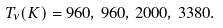Convert formula to latex. <formula><loc_0><loc_0><loc_500><loc_500>T _ { \nu } ( K ) = 9 6 0 , \, 9 6 0 , \, 2 0 0 0 , \, 3 3 8 0 .</formula> 